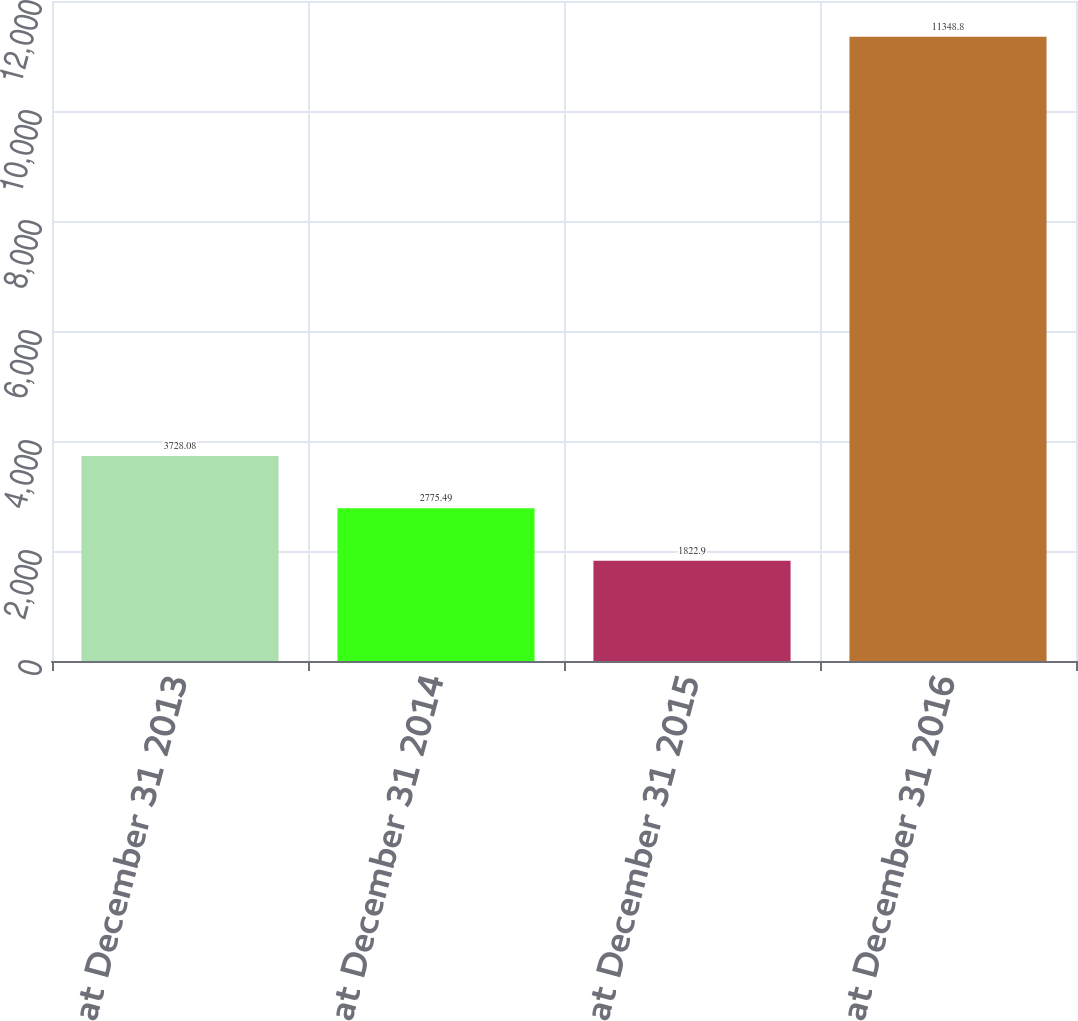<chart> <loc_0><loc_0><loc_500><loc_500><bar_chart><fcel>Balance at December 31 2013<fcel>Balance at December 31 2014<fcel>Balance at December 31 2015<fcel>Balance at December 31 2016<nl><fcel>3728.08<fcel>2775.49<fcel>1822.9<fcel>11348.8<nl></chart> 